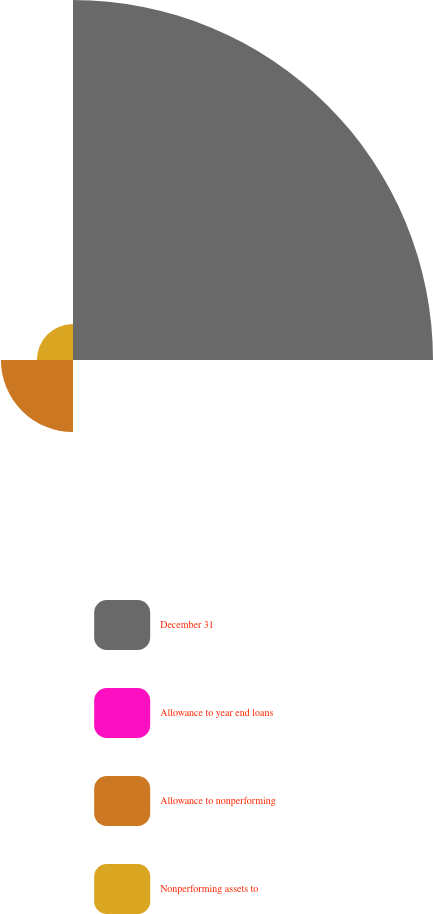Convert chart. <chart><loc_0><loc_0><loc_500><loc_500><pie_chart><fcel>December 31<fcel>Allowance to year end loans<fcel>Allowance to nonperforming<fcel>Nonperforming assets to<nl><fcel>76.88%<fcel>0.02%<fcel>15.39%<fcel>7.71%<nl></chart> 